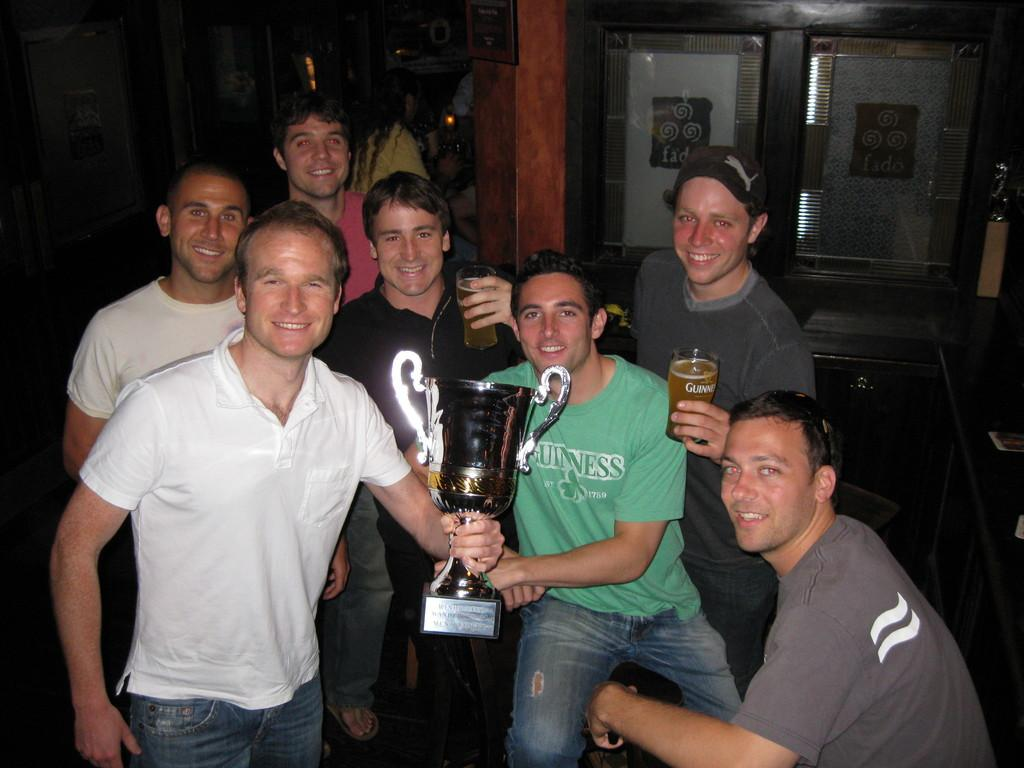What is the main subject of the image? The main subject of the image is a group of people. What are the people in the image doing? The people are standing in the image. Can you identify any specific actions or objects being held by the people? Yes, two persons are holding a trophy, and two other persons are holding glasses. What type of writing can be seen on the bed in the image? There is no bed or writing present in the image; it features a group of people standing, with some holding a trophy and others holding glasses. 